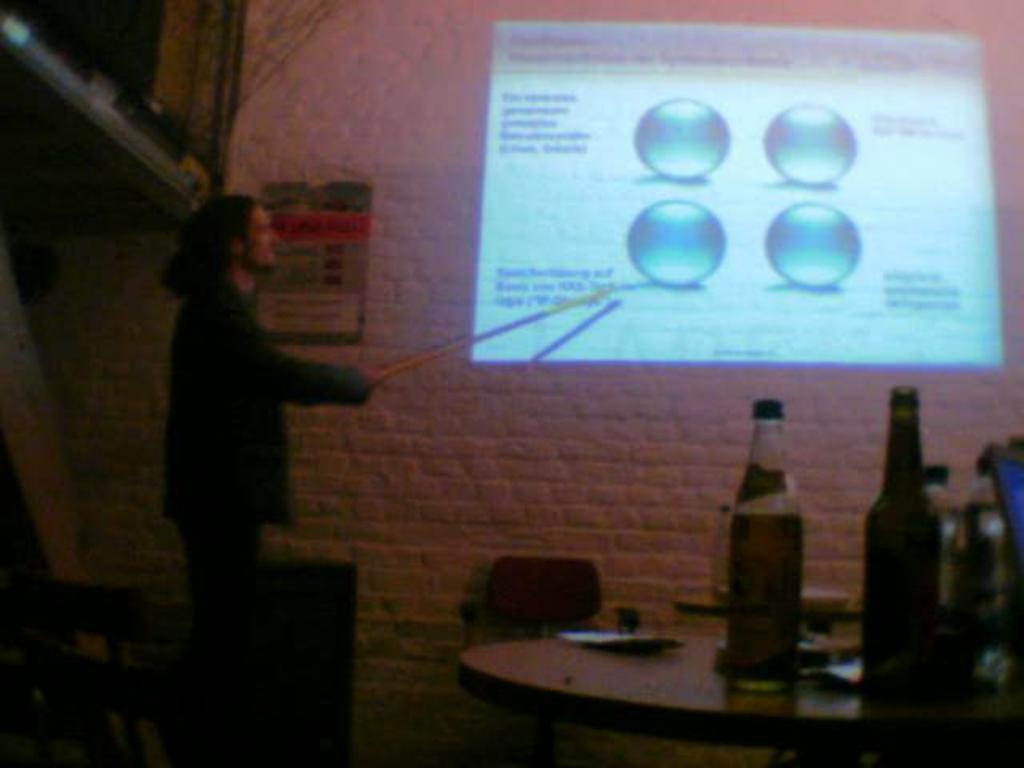Can you describe this image briefly? In this image i can see a person wearing green color shirt holding a stick and at the right side of the image there are bottles and at the middle of the image there is a projector screen. 